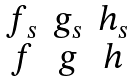Convert formula to latex. <formula><loc_0><loc_0><loc_500><loc_500>\begin{matrix} f _ { s } & g _ { s } & h _ { s } \\ f & g & h \end{matrix}</formula> 